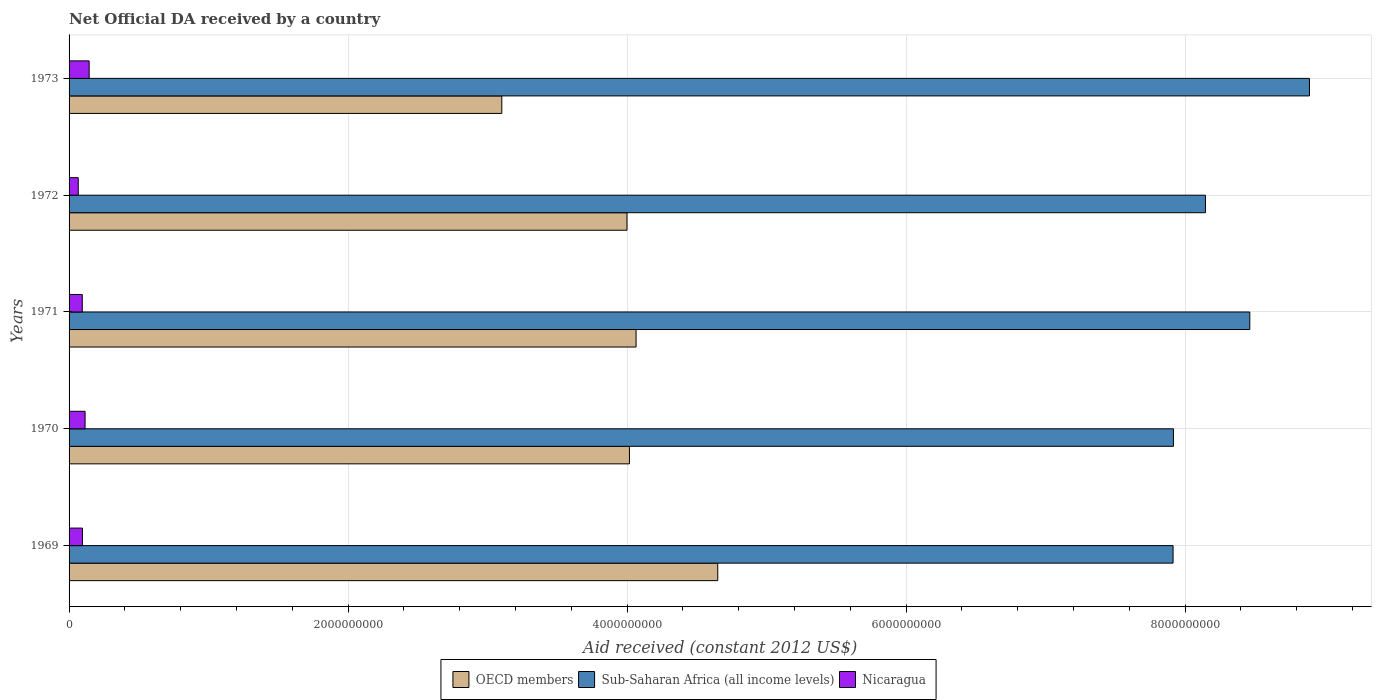Are the number of bars per tick equal to the number of legend labels?
Offer a very short reply. Yes. In how many cases, is the number of bars for a given year not equal to the number of legend labels?
Your response must be concise. 0. What is the net official development assistance aid received in OECD members in 1970?
Give a very brief answer. 4.02e+09. Across all years, what is the maximum net official development assistance aid received in Sub-Saharan Africa (all income levels)?
Your response must be concise. 8.89e+09. Across all years, what is the minimum net official development assistance aid received in Nicaragua?
Ensure brevity in your answer.  6.58e+07. In which year was the net official development assistance aid received in OECD members maximum?
Your answer should be compact. 1969. In which year was the net official development assistance aid received in Sub-Saharan Africa (all income levels) minimum?
Your answer should be very brief. 1969. What is the total net official development assistance aid received in Nicaragua in the graph?
Offer a very short reply. 5.15e+08. What is the difference between the net official development assistance aid received in Sub-Saharan Africa (all income levels) in 1971 and that in 1972?
Make the answer very short. 3.18e+08. What is the difference between the net official development assistance aid received in OECD members in 1973 and the net official development assistance aid received in Sub-Saharan Africa (all income levels) in 1972?
Keep it short and to the point. -5.04e+09. What is the average net official development assistance aid received in OECD members per year?
Offer a terse response. 3.97e+09. In the year 1971, what is the difference between the net official development assistance aid received in Sub-Saharan Africa (all income levels) and net official development assistance aid received in OECD members?
Ensure brevity in your answer.  4.40e+09. What is the ratio of the net official development assistance aid received in Sub-Saharan Africa (all income levels) in 1972 to that in 1973?
Offer a very short reply. 0.92. Is the net official development assistance aid received in Nicaragua in 1970 less than that in 1972?
Make the answer very short. No. Is the difference between the net official development assistance aid received in Sub-Saharan Africa (all income levels) in 1972 and 1973 greater than the difference between the net official development assistance aid received in OECD members in 1972 and 1973?
Your response must be concise. No. What is the difference between the highest and the second highest net official development assistance aid received in Nicaragua?
Your answer should be compact. 2.92e+07. What is the difference between the highest and the lowest net official development assistance aid received in Sub-Saharan Africa (all income levels)?
Offer a terse response. 9.78e+08. In how many years, is the net official development assistance aid received in OECD members greater than the average net official development assistance aid received in OECD members taken over all years?
Provide a short and direct response. 4. Is the sum of the net official development assistance aid received in OECD members in 1971 and 1973 greater than the maximum net official development assistance aid received in Sub-Saharan Africa (all income levels) across all years?
Make the answer very short. No. What does the 1st bar from the top in 1971 represents?
Offer a very short reply. Nicaragua. What does the 1st bar from the bottom in 1973 represents?
Offer a terse response. OECD members. Are all the bars in the graph horizontal?
Ensure brevity in your answer.  Yes. How many years are there in the graph?
Offer a terse response. 5. What is the difference between two consecutive major ticks on the X-axis?
Ensure brevity in your answer.  2.00e+09. Where does the legend appear in the graph?
Offer a terse response. Bottom center. How are the legend labels stacked?
Ensure brevity in your answer.  Horizontal. What is the title of the graph?
Make the answer very short. Net Official DA received by a country. What is the label or title of the X-axis?
Provide a short and direct response. Aid received (constant 2012 US$). What is the Aid received (constant 2012 US$) in OECD members in 1969?
Your response must be concise. 4.65e+09. What is the Aid received (constant 2012 US$) in Sub-Saharan Africa (all income levels) in 1969?
Your response must be concise. 7.91e+09. What is the Aid received (constant 2012 US$) in Nicaragua in 1969?
Keep it short and to the point. 9.58e+07. What is the Aid received (constant 2012 US$) of OECD members in 1970?
Your response must be concise. 4.02e+09. What is the Aid received (constant 2012 US$) in Sub-Saharan Africa (all income levels) in 1970?
Ensure brevity in your answer.  7.92e+09. What is the Aid received (constant 2012 US$) of Nicaragua in 1970?
Your answer should be compact. 1.15e+08. What is the Aid received (constant 2012 US$) of OECD members in 1971?
Provide a succinct answer. 4.06e+09. What is the Aid received (constant 2012 US$) in Sub-Saharan Africa (all income levels) in 1971?
Keep it short and to the point. 8.46e+09. What is the Aid received (constant 2012 US$) of Nicaragua in 1971?
Your response must be concise. 9.47e+07. What is the Aid received (constant 2012 US$) in OECD members in 1972?
Your response must be concise. 4.00e+09. What is the Aid received (constant 2012 US$) of Sub-Saharan Africa (all income levels) in 1972?
Provide a succinct answer. 8.15e+09. What is the Aid received (constant 2012 US$) in Nicaragua in 1972?
Make the answer very short. 6.58e+07. What is the Aid received (constant 2012 US$) in OECD members in 1973?
Offer a terse response. 3.10e+09. What is the Aid received (constant 2012 US$) of Sub-Saharan Africa (all income levels) in 1973?
Your answer should be compact. 8.89e+09. What is the Aid received (constant 2012 US$) in Nicaragua in 1973?
Make the answer very short. 1.44e+08. Across all years, what is the maximum Aid received (constant 2012 US$) in OECD members?
Provide a short and direct response. 4.65e+09. Across all years, what is the maximum Aid received (constant 2012 US$) of Sub-Saharan Africa (all income levels)?
Offer a terse response. 8.89e+09. Across all years, what is the maximum Aid received (constant 2012 US$) in Nicaragua?
Ensure brevity in your answer.  1.44e+08. Across all years, what is the minimum Aid received (constant 2012 US$) of OECD members?
Your answer should be very brief. 3.10e+09. Across all years, what is the minimum Aid received (constant 2012 US$) in Sub-Saharan Africa (all income levels)?
Ensure brevity in your answer.  7.91e+09. Across all years, what is the minimum Aid received (constant 2012 US$) of Nicaragua?
Provide a short and direct response. 6.58e+07. What is the total Aid received (constant 2012 US$) in OECD members in the graph?
Your answer should be very brief. 1.98e+1. What is the total Aid received (constant 2012 US$) in Sub-Saharan Africa (all income levels) in the graph?
Offer a very short reply. 4.13e+1. What is the total Aid received (constant 2012 US$) of Nicaragua in the graph?
Make the answer very short. 5.15e+08. What is the difference between the Aid received (constant 2012 US$) of OECD members in 1969 and that in 1970?
Ensure brevity in your answer.  6.33e+08. What is the difference between the Aid received (constant 2012 US$) in Sub-Saharan Africa (all income levels) in 1969 and that in 1970?
Give a very brief answer. -2.54e+06. What is the difference between the Aid received (constant 2012 US$) in Nicaragua in 1969 and that in 1970?
Provide a short and direct response. -1.89e+07. What is the difference between the Aid received (constant 2012 US$) in OECD members in 1969 and that in 1971?
Give a very brief answer. 5.85e+08. What is the difference between the Aid received (constant 2012 US$) of Sub-Saharan Africa (all income levels) in 1969 and that in 1971?
Your response must be concise. -5.50e+08. What is the difference between the Aid received (constant 2012 US$) of Nicaragua in 1969 and that in 1971?
Make the answer very short. 1.07e+06. What is the difference between the Aid received (constant 2012 US$) in OECD members in 1969 and that in 1972?
Offer a terse response. 6.51e+08. What is the difference between the Aid received (constant 2012 US$) of Sub-Saharan Africa (all income levels) in 1969 and that in 1972?
Provide a succinct answer. -2.32e+08. What is the difference between the Aid received (constant 2012 US$) in Nicaragua in 1969 and that in 1972?
Provide a succinct answer. 3.00e+07. What is the difference between the Aid received (constant 2012 US$) in OECD members in 1969 and that in 1973?
Provide a succinct answer. 1.55e+09. What is the difference between the Aid received (constant 2012 US$) of Sub-Saharan Africa (all income levels) in 1969 and that in 1973?
Make the answer very short. -9.78e+08. What is the difference between the Aid received (constant 2012 US$) in Nicaragua in 1969 and that in 1973?
Give a very brief answer. -4.82e+07. What is the difference between the Aid received (constant 2012 US$) in OECD members in 1970 and that in 1971?
Provide a short and direct response. -4.75e+07. What is the difference between the Aid received (constant 2012 US$) in Sub-Saharan Africa (all income levels) in 1970 and that in 1971?
Keep it short and to the point. -5.47e+08. What is the difference between the Aid received (constant 2012 US$) of Nicaragua in 1970 and that in 1971?
Make the answer very short. 2.00e+07. What is the difference between the Aid received (constant 2012 US$) in OECD members in 1970 and that in 1972?
Offer a terse response. 1.76e+07. What is the difference between the Aid received (constant 2012 US$) of Sub-Saharan Africa (all income levels) in 1970 and that in 1972?
Make the answer very short. -2.30e+08. What is the difference between the Aid received (constant 2012 US$) of Nicaragua in 1970 and that in 1972?
Ensure brevity in your answer.  4.89e+07. What is the difference between the Aid received (constant 2012 US$) in OECD members in 1970 and that in 1973?
Keep it short and to the point. 9.15e+08. What is the difference between the Aid received (constant 2012 US$) of Sub-Saharan Africa (all income levels) in 1970 and that in 1973?
Make the answer very short. -9.75e+08. What is the difference between the Aid received (constant 2012 US$) in Nicaragua in 1970 and that in 1973?
Your answer should be compact. -2.92e+07. What is the difference between the Aid received (constant 2012 US$) of OECD members in 1971 and that in 1972?
Your response must be concise. 6.51e+07. What is the difference between the Aid received (constant 2012 US$) in Sub-Saharan Africa (all income levels) in 1971 and that in 1972?
Make the answer very short. 3.18e+08. What is the difference between the Aid received (constant 2012 US$) in Nicaragua in 1971 and that in 1972?
Offer a terse response. 2.89e+07. What is the difference between the Aid received (constant 2012 US$) in OECD members in 1971 and that in 1973?
Your answer should be very brief. 9.63e+08. What is the difference between the Aid received (constant 2012 US$) in Sub-Saharan Africa (all income levels) in 1971 and that in 1973?
Offer a terse response. -4.28e+08. What is the difference between the Aid received (constant 2012 US$) in Nicaragua in 1971 and that in 1973?
Provide a short and direct response. -4.92e+07. What is the difference between the Aid received (constant 2012 US$) in OECD members in 1972 and that in 1973?
Your response must be concise. 8.98e+08. What is the difference between the Aid received (constant 2012 US$) of Sub-Saharan Africa (all income levels) in 1972 and that in 1973?
Your answer should be compact. -7.46e+08. What is the difference between the Aid received (constant 2012 US$) in Nicaragua in 1972 and that in 1973?
Your answer should be very brief. -7.81e+07. What is the difference between the Aid received (constant 2012 US$) of OECD members in 1969 and the Aid received (constant 2012 US$) of Sub-Saharan Africa (all income levels) in 1970?
Make the answer very short. -3.27e+09. What is the difference between the Aid received (constant 2012 US$) of OECD members in 1969 and the Aid received (constant 2012 US$) of Nicaragua in 1970?
Give a very brief answer. 4.54e+09. What is the difference between the Aid received (constant 2012 US$) in Sub-Saharan Africa (all income levels) in 1969 and the Aid received (constant 2012 US$) in Nicaragua in 1970?
Keep it short and to the point. 7.80e+09. What is the difference between the Aid received (constant 2012 US$) in OECD members in 1969 and the Aid received (constant 2012 US$) in Sub-Saharan Africa (all income levels) in 1971?
Ensure brevity in your answer.  -3.81e+09. What is the difference between the Aid received (constant 2012 US$) of OECD members in 1969 and the Aid received (constant 2012 US$) of Nicaragua in 1971?
Make the answer very short. 4.56e+09. What is the difference between the Aid received (constant 2012 US$) of Sub-Saharan Africa (all income levels) in 1969 and the Aid received (constant 2012 US$) of Nicaragua in 1971?
Ensure brevity in your answer.  7.82e+09. What is the difference between the Aid received (constant 2012 US$) in OECD members in 1969 and the Aid received (constant 2012 US$) in Sub-Saharan Africa (all income levels) in 1972?
Make the answer very short. -3.50e+09. What is the difference between the Aid received (constant 2012 US$) in OECD members in 1969 and the Aid received (constant 2012 US$) in Nicaragua in 1972?
Your response must be concise. 4.58e+09. What is the difference between the Aid received (constant 2012 US$) in Sub-Saharan Africa (all income levels) in 1969 and the Aid received (constant 2012 US$) in Nicaragua in 1972?
Offer a terse response. 7.85e+09. What is the difference between the Aid received (constant 2012 US$) in OECD members in 1969 and the Aid received (constant 2012 US$) in Sub-Saharan Africa (all income levels) in 1973?
Offer a terse response. -4.24e+09. What is the difference between the Aid received (constant 2012 US$) in OECD members in 1969 and the Aid received (constant 2012 US$) in Nicaragua in 1973?
Keep it short and to the point. 4.51e+09. What is the difference between the Aid received (constant 2012 US$) of Sub-Saharan Africa (all income levels) in 1969 and the Aid received (constant 2012 US$) of Nicaragua in 1973?
Provide a succinct answer. 7.77e+09. What is the difference between the Aid received (constant 2012 US$) of OECD members in 1970 and the Aid received (constant 2012 US$) of Sub-Saharan Africa (all income levels) in 1971?
Offer a terse response. -4.45e+09. What is the difference between the Aid received (constant 2012 US$) in OECD members in 1970 and the Aid received (constant 2012 US$) in Nicaragua in 1971?
Offer a terse response. 3.92e+09. What is the difference between the Aid received (constant 2012 US$) of Sub-Saharan Africa (all income levels) in 1970 and the Aid received (constant 2012 US$) of Nicaragua in 1971?
Offer a very short reply. 7.82e+09. What is the difference between the Aid received (constant 2012 US$) in OECD members in 1970 and the Aid received (constant 2012 US$) in Sub-Saharan Africa (all income levels) in 1972?
Keep it short and to the point. -4.13e+09. What is the difference between the Aid received (constant 2012 US$) in OECD members in 1970 and the Aid received (constant 2012 US$) in Nicaragua in 1972?
Your answer should be compact. 3.95e+09. What is the difference between the Aid received (constant 2012 US$) of Sub-Saharan Africa (all income levels) in 1970 and the Aid received (constant 2012 US$) of Nicaragua in 1972?
Keep it short and to the point. 7.85e+09. What is the difference between the Aid received (constant 2012 US$) in OECD members in 1970 and the Aid received (constant 2012 US$) in Sub-Saharan Africa (all income levels) in 1973?
Ensure brevity in your answer.  -4.87e+09. What is the difference between the Aid received (constant 2012 US$) of OECD members in 1970 and the Aid received (constant 2012 US$) of Nicaragua in 1973?
Make the answer very short. 3.87e+09. What is the difference between the Aid received (constant 2012 US$) in Sub-Saharan Africa (all income levels) in 1970 and the Aid received (constant 2012 US$) in Nicaragua in 1973?
Offer a terse response. 7.77e+09. What is the difference between the Aid received (constant 2012 US$) in OECD members in 1971 and the Aid received (constant 2012 US$) in Sub-Saharan Africa (all income levels) in 1972?
Ensure brevity in your answer.  -4.08e+09. What is the difference between the Aid received (constant 2012 US$) in OECD members in 1971 and the Aid received (constant 2012 US$) in Nicaragua in 1972?
Give a very brief answer. 4.00e+09. What is the difference between the Aid received (constant 2012 US$) in Sub-Saharan Africa (all income levels) in 1971 and the Aid received (constant 2012 US$) in Nicaragua in 1972?
Make the answer very short. 8.40e+09. What is the difference between the Aid received (constant 2012 US$) in OECD members in 1971 and the Aid received (constant 2012 US$) in Sub-Saharan Africa (all income levels) in 1973?
Give a very brief answer. -4.83e+09. What is the difference between the Aid received (constant 2012 US$) in OECD members in 1971 and the Aid received (constant 2012 US$) in Nicaragua in 1973?
Give a very brief answer. 3.92e+09. What is the difference between the Aid received (constant 2012 US$) in Sub-Saharan Africa (all income levels) in 1971 and the Aid received (constant 2012 US$) in Nicaragua in 1973?
Provide a short and direct response. 8.32e+09. What is the difference between the Aid received (constant 2012 US$) of OECD members in 1972 and the Aid received (constant 2012 US$) of Sub-Saharan Africa (all income levels) in 1973?
Make the answer very short. -4.89e+09. What is the difference between the Aid received (constant 2012 US$) of OECD members in 1972 and the Aid received (constant 2012 US$) of Nicaragua in 1973?
Make the answer very short. 3.86e+09. What is the difference between the Aid received (constant 2012 US$) of Sub-Saharan Africa (all income levels) in 1972 and the Aid received (constant 2012 US$) of Nicaragua in 1973?
Offer a very short reply. 8.00e+09. What is the average Aid received (constant 2012 US$) in OECD members per year?
Make the answer very short. 3.97e+09. What is the average Aid received (constant 2012 US$) in Sub-Saharan Africa (all income levels) per year?
Your response must be concise. 8.27e+09. What is the average Aid received (constant 2012 US$) of Nicaragua per year?
Your answer should be compact. 1.03e+08. In the year 1969, what is the difference between the Aid received (constant 2012 US$) of OECD members and Aid received (constant 2012 US$) of Sub-Saharan Africa (all income levels)?
Provide a succinct answer. -3.26e+09. In the year 1969, what is the difference between the Aid received (constant 2012 US$) in OECD members and Aid received (constant 2012 US$) in Nicaragua?
Your answer should be compact. 4.55e+09. In the year 1969, what is the difference between the Aid received (constant 2012 US$) of Sub-Saharan Africa (all income levels) and Aid received (constant 2012 US$) of Nicaragua?
Your answer should be very brief. 7.82e+09. In the year 1970, what is the difference between the Aid received (constant 2012 US$) in OECD members and Aid received (constant 2012 US$) in Sub-Saharan Africa (all income levels)?
Give a very brief answer. -3.90e+09. In the year 1970, what is the difference between the Aid received (constant 2012 US$) of OECD members and Aid received (constant 2012 US$) of Nicaragua?
Ensure brevity in your answer.  3.90e+09. In the year 1970, what is the difference between the Aid received (constant 2012 US$) in Sub-Saharan Africa (all income levels) and Aid received (constant 2012 US$) in Nicaragua?
Your response must be concise. 7.80e+09. In the year 1971, what is the difference between the Aid received (constant 2012 US$) in OECD members and Aid received (constant 2012 US$) in Sub-Saharan Africa (all income levels)?
Provide a succinct answer. -4.40e+09. In the year 1971, what is the difference between the Aid received (constant 2012 US$) of OECD members and Aid received (constant 2012 US$) of Nicaragua?
Give a very brief answer. 3.97e+09. In the year 1971, what is the difference between the Aid received (constant 2012 US$) of Sub-Saharan Africa (all income levels) and Aid received (constant 2012 US$) of Nicaragua?
Keep it short and to the point. 8.37e+09. In the year 1972, what is the difference between the Aid received (constant 2012 US$) in OECD members and Aid received (constant 2012 US$) in Sub-Saharan Africa (all income levels)?
Give a very brief answer. -4.15e+09. In the year 1972, what is the difference between the Aid received (constant 2012 US$) of OECD members and Aid received (constant 2012 US$) of Nicaragua?
Your response must be concise. 3.93e+09. In the year 1972, what is the difference between the Aid received (constant 2012 US$) in Sub-Saharan Africa (all income levels) and Aid received (constant 2012 US$) in Nicaragua?
Keep it short and to the point. 8.08e+09. In the year 1973, what is the difference between the Aid received (constant 2012 US$) in OECD members and Aid received (constant 2012 US$) in Sub-Saharan Africa (all income levels)?
Ensure brevity in your answer.  -5.79e+09. In the year 1973, what is the difference between the Aid received (constant 2012 US$) in OECD members and Aid received (constant 2012 US$) in Nicaragua?
Make the answer very short. 2.96e+09. In the year 1973, what is the difference between the Aid received (constant 2012 US$) of Sub-Saharan Africa (all income levels) and Aid received (constant 2012 US$) of Nicaragua?
Offer a very short reply. 8.75e+09. What is the ratio of the Aid received (constant 2012 US$) of OECD members in 1969 to that in 1970?
Offer a very short reply. 1.16. What is the ratio of the Aid received (constant 2012 US$) of Sub-Saharan Africa (all income levels) in 1969 to that in 1970?
Ensure brevity in your answer.  1. What is the ratio of the Aid received (constant 2012 US$) in Nicaragua in 1969 to that in 1970?
Provide a short and direct response. 0.83. What is the ratio of the Aid received (constant 2012 US$) in OECD members in 1969 to that in 1971?
Ensure brevity in your answer.  1.14. What is the ratio of the Aid received (constant 2012 US$) in Sub-Saharan Africa (all income levels) in 1969 to that in 1971?
Provide a succinct answer. 0.94. What is the ratio of the Aid received (constant 2012 US$) of Nicaragua in 1969 to that in 1971?
Your answer should be compact. 1.01. What is the ratio of the Aid received (constant 2012 US$) in OECD members in 1969 to that in 1972?
Your answer should be very brief. 1.16. What is the ratio of the Aid received (constant 2012 US$) of Sub-Saharan Africa (all income levels) in 1969 to that in 1972?
Your answer should be very brief. 0.97. What is the ratio of the Aid received (constant 2012 US$) of Nicaragua in 1969 to that in 1972?
Provide a succinct answer. 1.46. What is the ratio of the Aid received (constant 2012 US$) of OECD members in 1969 to that in 1973?
Keep it short and to the point. 1.5. What is the ratio of the Aid received (constant 2012 US$) of Sub-Saharan Africa (all income levels) in 1969 to that in 1973?
Your answer should be very brief. 0.89. What is the ratio of the Aid received (constant 2012 US$) in Nicaragua in 1969 to that in 1973?
Your answer should be compact. 0.67. What is the ratio of the Aid received (constant 2012 US$) of OECD members in 1970 to that in 1971?
Ensure brevity in your answer.  0.99. What is the ratio of the Aid received (constant 2012 US$) of Sub-Saharan Africa (all income levels) in 1970 to that in 1971?
Make the answer very short. 0.94. What is the ratio of the Aid received (constant 2012 US$) in Nicaragua in 1970 to that in 1971?
Your answer should be very brief. 1.21. What is the ratio of the Aid received (constant 2012 US$) of OECD members in 1970 to that in 1972?
Make the answer very short. 1. What is the ratio of the Aid received (constant 2012 US$) in Sub-Saharan Africa (all income levels) in 1970 to that in 1972?
Ensure brevity in your answer.  0.97. What is the ratio of the Aid received (constant 2012 US$) in Nicaragua in 1970 to that in 1972?
Provide a succinct answer. 1.74. What is the ratio of the Aid received (constant 2012 US$) of OECD members in 1970 to that in 1973?
Give a very brief answer. 1.29. What is the ratio of the Aid received (constant 2012 US$) in Sub-Saharan Africa (all income levels) in 1970 to that in 1973?
Make the answer very short. 0.89. What is the ratio of the Aid received (constant 2012 US$) of Nicaragua in 1970 to that in 1973?
Your response must be concise. 0.8. What is the ratio of the Aid received (constant 2012 US$) in OECD members in 1971 to that in 1972?
Make the answer very short. 1.02. What is the ratio of the Aid received (constant 2012 US$) of Sub-Saharan Africa (all income levels) in 1971 to that in 1972?
Offer a very short reply. 1.04. What is the ratio of the Aid received (constant 2012 US$) in Nicaragua in 1971 to that in 1972?
Make the answer very short. 1.44. What is the ratio of the Aid received (constant 2012 US$) in OECD members in 1971 to that in 1973?
Your answer should be very brief. 1.31. What is the ratio of the Aid received (constant 2012 US$) of Sub-Saharan Africa (all income levels) in 1971 to that in 1973?
Keep it short and to the point. 0.95. What is the ratio of the Aid received (constant 2012 US$) in Nicaragua in 1971 to that in 1973?
Offer a very short reply. 0.66. What is the ratio of the Aid received (constant 2012 US$) of OECD members in 1972 to that in 1973?
Offer a terse response. 1.29. What is the ratio of the Aid received (constant 2012 US$) of Sub-Saharan Africa (all income levels) in 1972 to that in 1973?
Offer a very short reply. 0.92. What is the ratio of the Aid received (constant 2012 US$) of Nicaragua in 1972 to that in 1973?
Offer a terse response. 0.46. What is the difference between the highest and the second highest Aid received (constant 2012 US$) of OECD members?
Provide a short and direct response. 5.85e+08. What is the difference between the highest and the second highest Aid received (constant 2012 US$) in Sub-Saharan Africa (all income levels)?
Give a very brief answer. 4.28e+08. What is the difference between the highest and the second highest Aid received (constant 2012 US$) of Nicaragua?
Keep it short and to the point. 2.92e+07. What is the difference between the highest and the lowest Aid received (constant 2012 US$) of OECD members?
Your response must be concise. 1.55e+09. What is the difference between the highest and the lowest Aid received (constant 2012 US$) in Sub-Saharan Africa (all income levels)?
Your answer should be very brief. 9.78e+08. What is the difference between the highest and the lowest Aid received (constant 2012 US$) in Nicaragua?
Your response must be concise. 7.81e+07. 